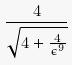Convert formula to latex. <formula><loc_0><loc_0><loc_500><loc_500>\frac { 4 } { \sqrt { 4 + \frac { 4 } { \epsilon ^ { 9 } } } }</formula> 